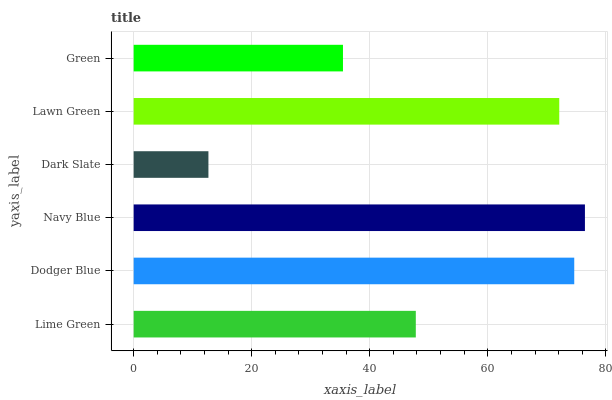Is Dark Slate the minimum?
Answer yes or no. Yes. Is Navy Blue the maximum?
Answer yes or no. Yes. Is Dodger Blue the minimum?
Answer yes or no. No. Is Dodger Blue the maximum?
Answer yes or no. No. Is Dodger Blue greater than Lime Green?
Answer yes or no. Yes. Is Lime Green less than Dodger Blue?
Answer yes or no. Yes. Is Lime Green greater than Dodger Blue?
Answer yes or no. No. Is Dodger Blue less than Lime Green?
Answer yes or no. No. Is Lawn Green the high median?
Answer yes or no. Yes. Is Lime Green the low median?
Answer yes or no. Yes. Is Dodger Blue the high median?
Answer yes or no. No. Is Dodger Blue the low median?
Answer yes or no. No. 